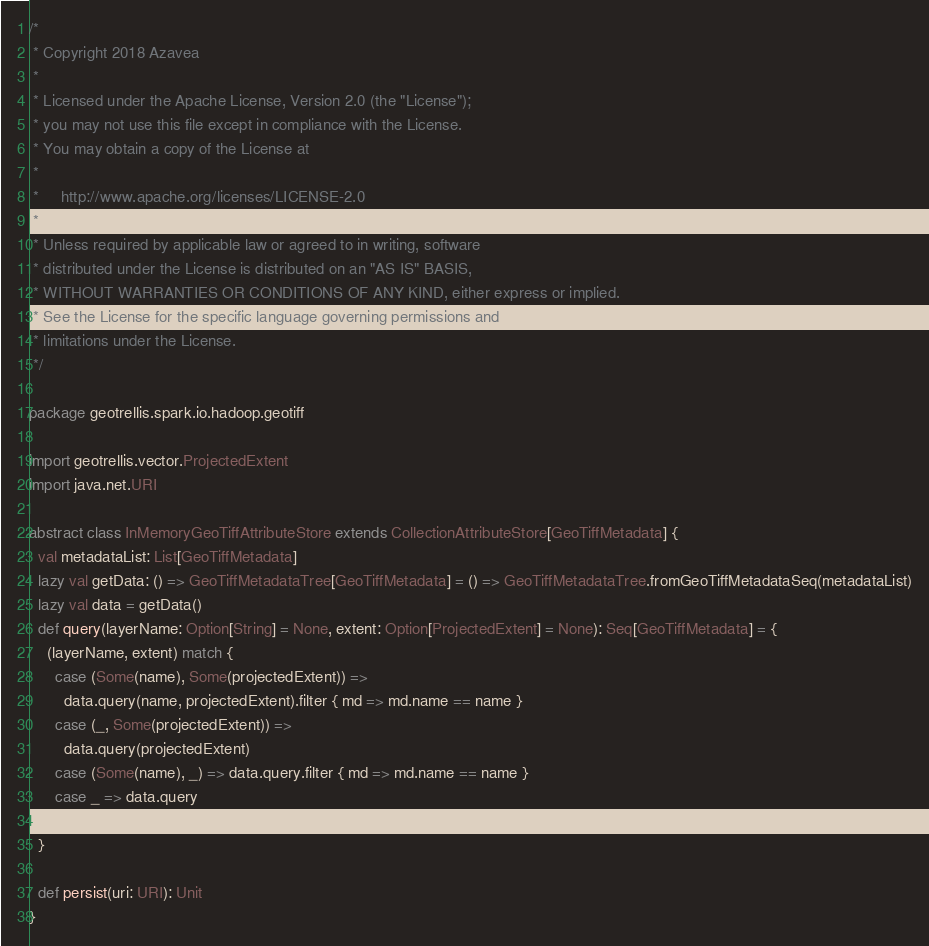Convert code to text. <code><loc_0><loc_0><loc_500><loc_500><_Scala_>/*
 * Copyright 2018 Azavea
 *
 * Licensed under the Apache License, Version 2.0 (the "License");
 * you may not use this file except in compliance with the License.
 * You may obtain a copy of the License at
 *
 *     http://www.apache.org/licenses/LICENSE-2.0
 *
 * Unless required by applicable law or agreed to in writing, software
 * distributed under the License is distributed on an "AS IS" BASIS,
 * WITHOUT WARRANTIES OR CONDITIONS OF ANY KIND, either express or implied.
 * See the License for the specific language governing permissions and
 * limitations under the License.
 */

package geotrellis.spark.io.hadoop.geotiff

import geotrellis.vector.ProjectedExtent
import java.net.URI

abstract class InMemoryGeoTiffAttributeStore extends CollectionAttributeStore[GeoTiffMetadata] {
  val metadataList: List[GeoTiffMetadata]
  lazy val getData: () => GeoTiffMetadataTree[GeoTiffMetadata] = () => GeoTiffMetadataTree.fromGeoTiffMetadataSeq(metadataList)
  lazy val data = getData()
  def query(layerName: Option[String] = None, extent: Option[ProjectedExtent] = None): Seq[GeoTiffMetadata] = {
    (layerName, extent) match {
      case (Some(name), Some(projectedExtent)) =>
        data.query(name, projectedExtent).filter { md => md.name == name }
      case (_, Some(projectedExtent)) =>
        data.query(projectedExtent)
      case (Some(name), _) => data.query.filter { md => md.name == name }
      case _ => data.query
    }
  }

  def persist(uri: URI): Unit
}
</code> 